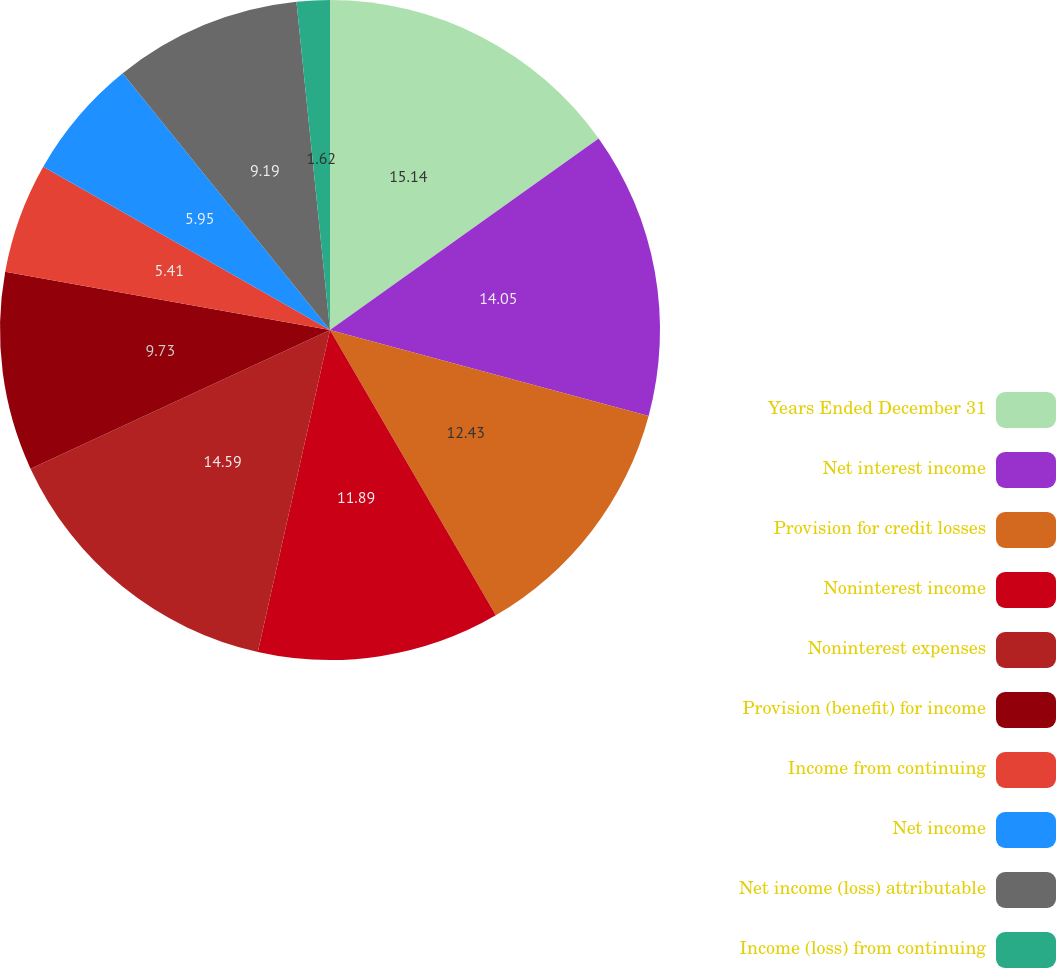Convert chart to OTSL. <chart><loc_0><loc_0><loc_500><loc_500><pie_chart><fcel>Years Ended December 31<fcel>Net interest income<fcel>Provision for credit losses<fcel>Noninterest income<fcel>Noninterest expenses<fcel>Provision (benefit) for income<fcel>Income from continuing<fcel>Net income<fcel>Net income (loss) attributable<fcel>Income (loss) from continuing<nl><fcel>15.14%<fcel>14.05%<fcel>12.43%<fcel>11.89%<fcel>14.59%<fcel>9.73%<fcel>5.41%<fcel>5.95%<fcel>9.19%<fcel>1.62%<nl></chart> 